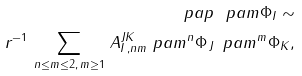Convert formula to latex. <formula><loc_0><loc_0><loc_500><loc_500>\ p a p \ p a m \Phi _ { I } \sim \\ { r } ^ { - 1 } \, \sum _ { n \leq m \leq 2 , \, m \geq 1 } \, A _ { I \, , n m } ^ { J K } \ p a m ^ { n } \Phi _ { \, J } \, \ p a m ^ { m } \Phi _ { K } ,</formula> 